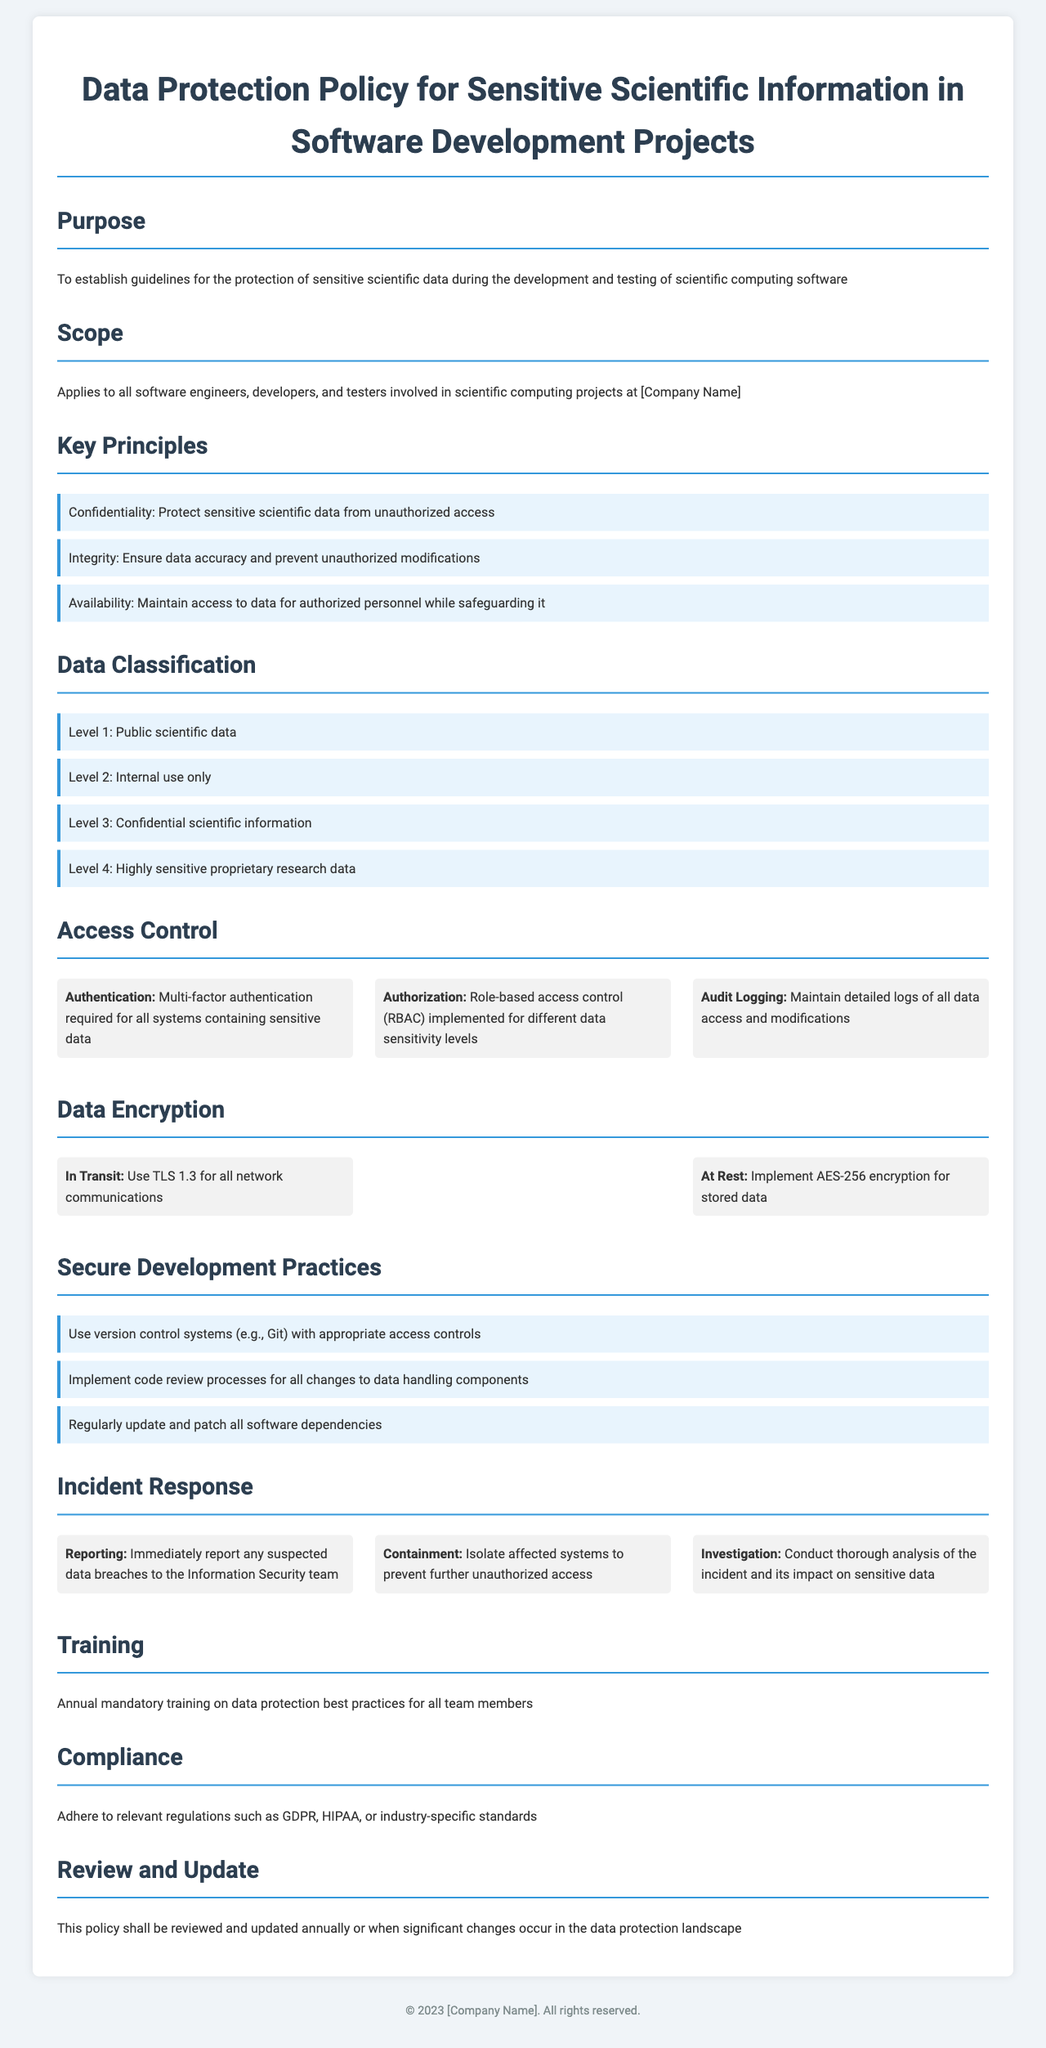What is the purpose of the policy? The purpose is stated to establish guidelines for the protection of sensitive scientific data during the development and testing of scientific computing software.
Answer: To establish guidelines for the protection of sensitive scientific data What does the policy apply to? The scope specifies it applies to all software engineers, developers, and testers involved in scientific computing projects at the company.
Answer: All software engineers, developers, and testers What is the highest data classification level? The data classification section lists the levels, with Level 4 being the highest, indicating the most sensitive data.
Answer: Level 4 What is required for authentication according to access control? The access control section mandates multi-factor authentication for all systems containing sensitive data.
Answer: Multi-factor authentication What encryption standard is mentioned for data at rest? The data encryption section specifies AES-256 encryption for stored data.
Answer: AES-256 encryption How often should training on data protection best practices occur? The training section indicates that annual mandatory training is required for all team members.
Answer: Annual What should be done immediately after a suspected data breach? The incident response section states that suspected data breaches must be reported immediately to the Information Security team.
Answer: Report to the Information Security team What is the main compliance requirement mentioned in the policy? The compliance section emphasizes adhering to relevant regulations such as GDPR or HIPAA.
Answer: Adhere to relevant regulations 